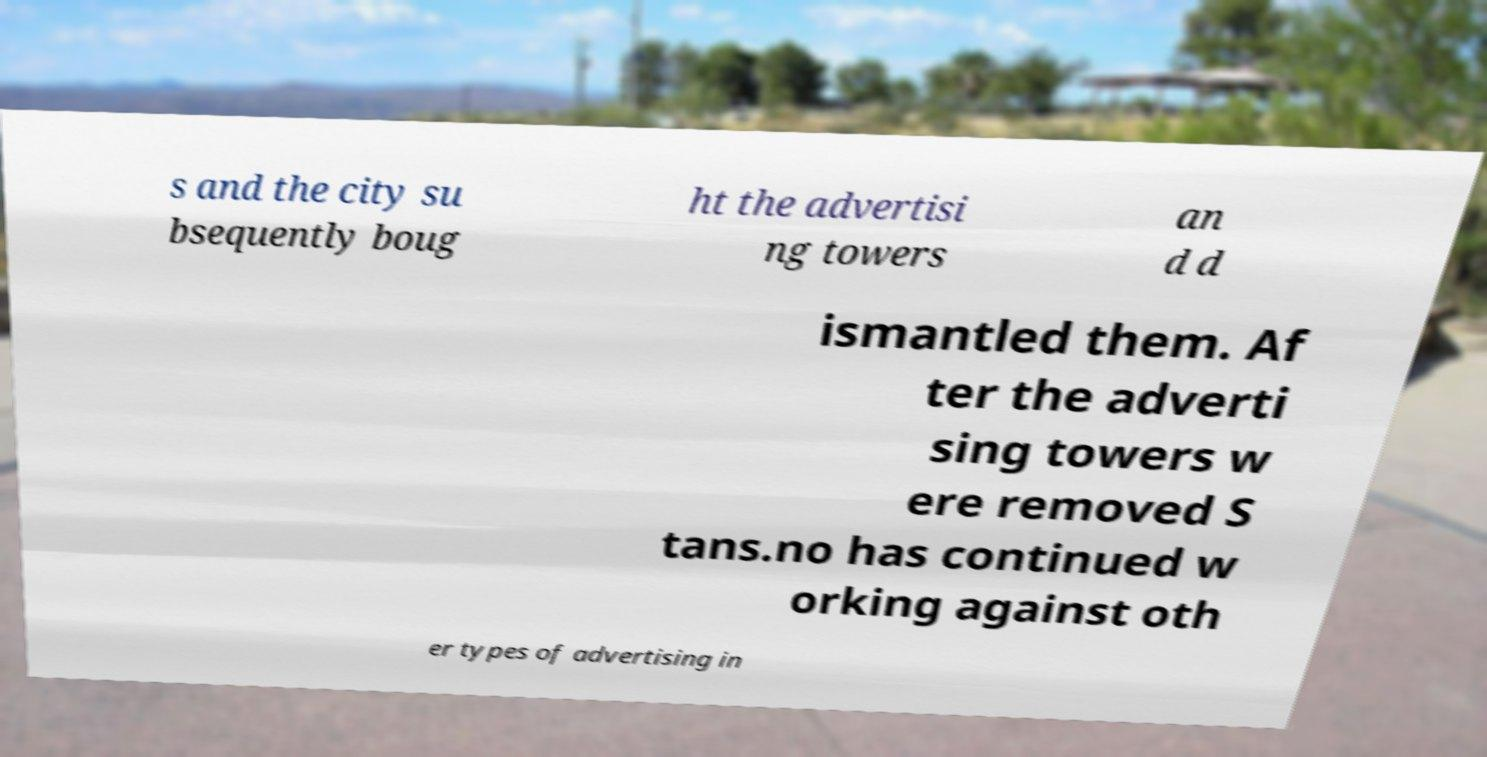What messages or text are displayed in this image? I need them in a readable, typed format. s and the city su bsequently boug ht the advertisi ng towers an d d ismantled them. Af ter the adverti sing towers w ere removed S tans.no has continued w orking against oth er types of advertising in 